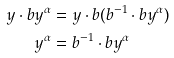<formula> <loc_0><loc_0><loc_500><loc_500>y \cdot b y ^ { \alpha } & = y \cdot b ( b ^ { - 1 } \cdot b y ^ { \alpha } ) & \\ y ^ { \alpha } & = b ^ { - 1 } \cdot b y ^ { \alpha }</formula> 